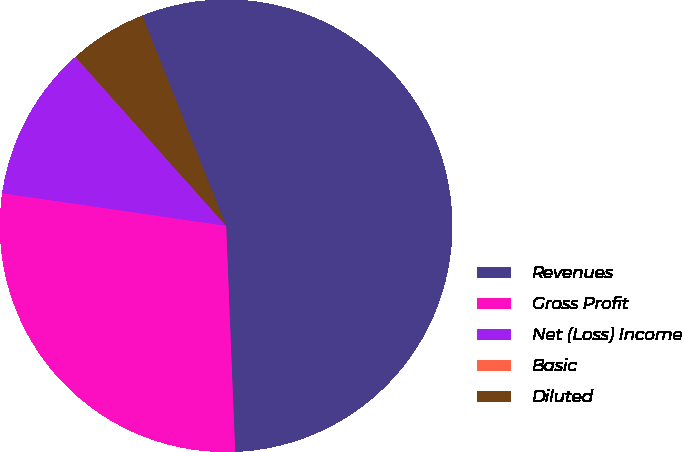Convert chart to OTSL. <chart><loc_0><loc_0><loc_500><loc_500><pie_chart><fcel>Revenues<fcel>Gross Profit<fcel>Net (Loss) Income<fcel>Basic<fcel>Diluted<nl><fcel>55.41%<fcel>27.94%<fcel>11.09%<fcel>0.01%<fcel>5.55%<nl></chart> 